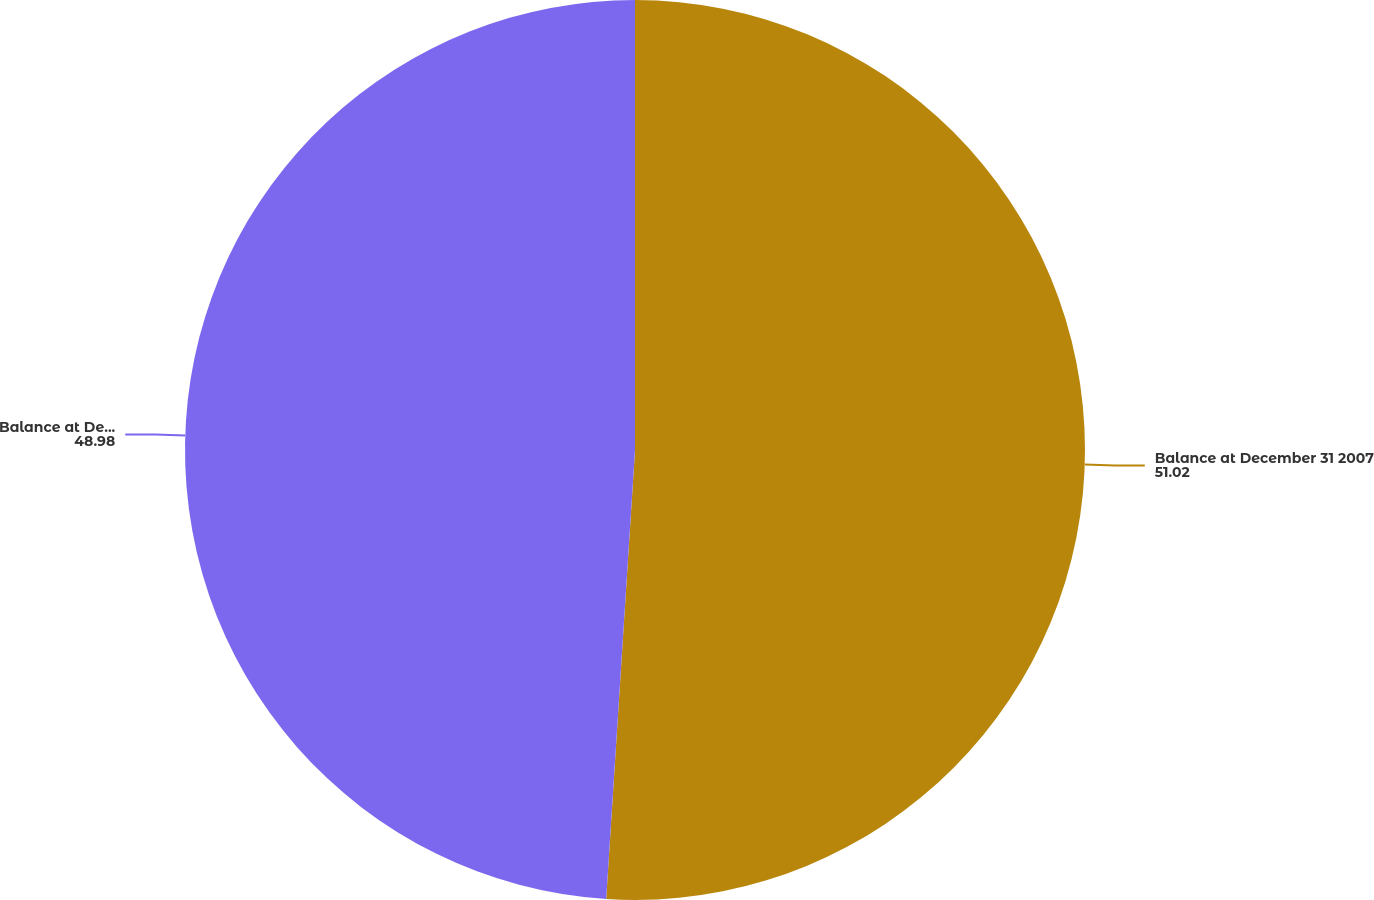<chart> <loc_0><loc_0><loc_500><loc_500><pie_chart><fcel>Balance at December 31 2007<fcel>Balance at December 31 2008<nl><fcel>51.02%<fcel>48.98%<nl></chart> 